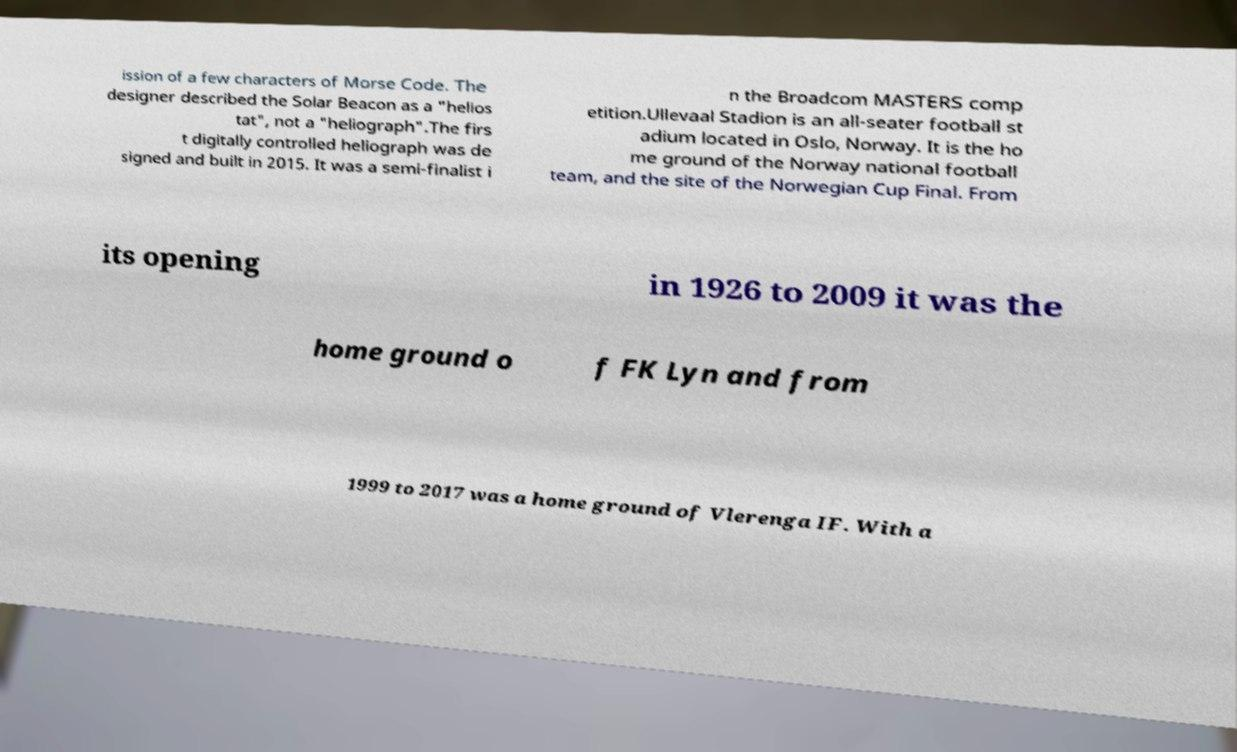For documentation purposes, I need the text within this image transcribed. Could you provide that? ission of a few characters of Morse Code. The designer described the Solar Beacon as a "helios tat", not a "heliograph".The firs t digitally controlled heliograph was de signed and built in 2015. It was a semi-finalist i n the Broadcom MASTERS comp etition.Ullevaal Stadion is an all-seater football st adium located in Oslo, Norway. It is the ho me ground of the Norway national football team, and the site of the Norwegian Cup Final. From its opening in 1926 to 2009 it was the home ground o f FK Lyn and from 1999 to 2017 was a home ground of Vlerenga IF. With a 